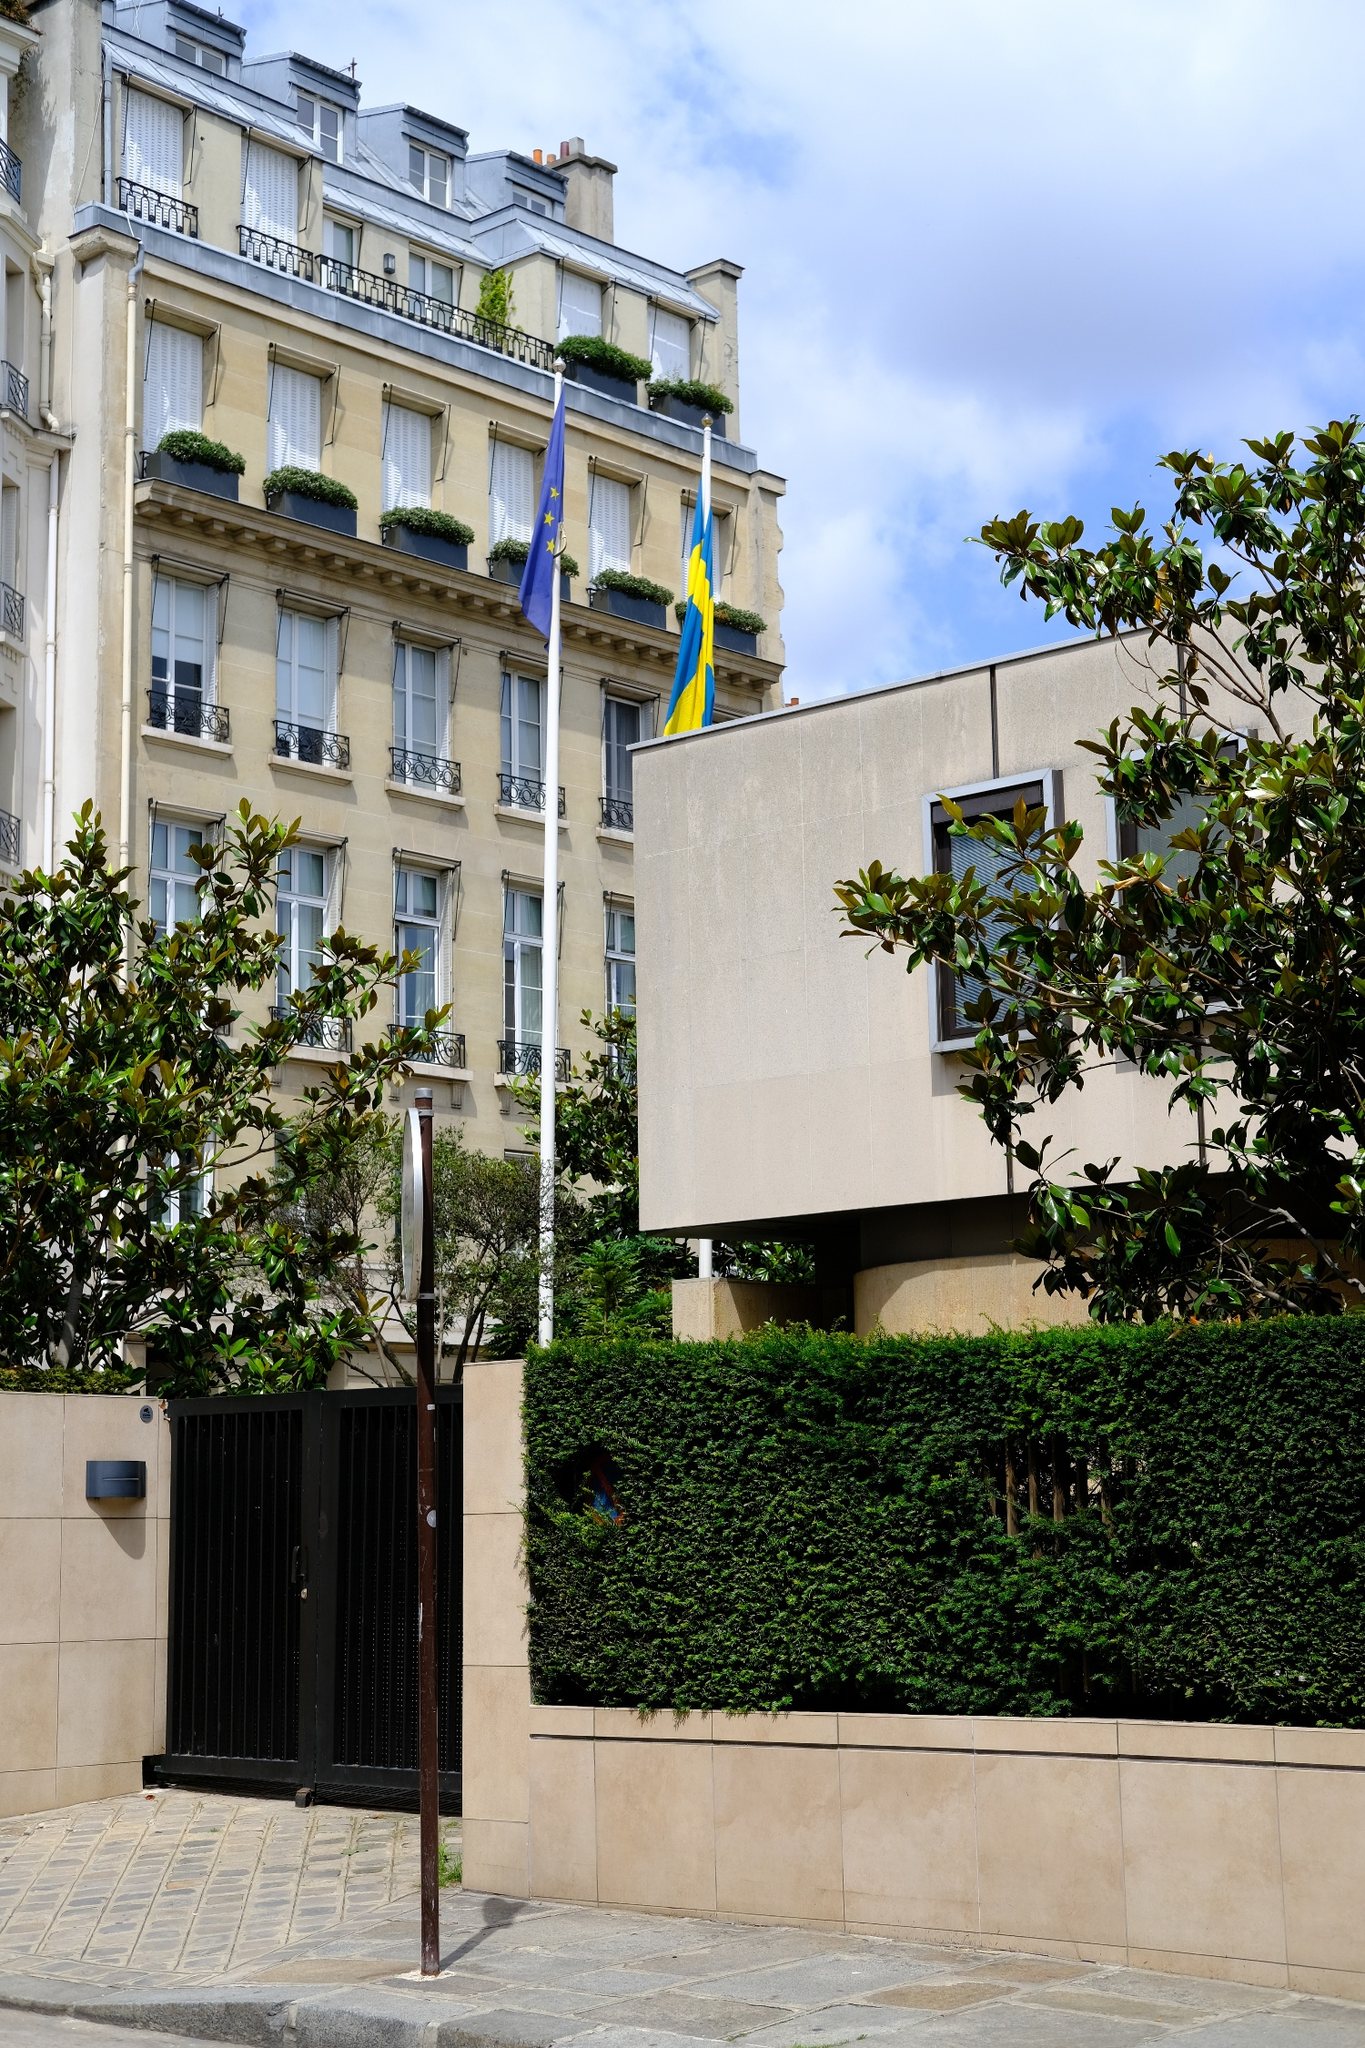Imagine you are a bird flying over this scene. Describe what you see from above. As a bird soaring overhead, the cityscape unfolds beneath in a breathtaking panorama. Below, the stately beige building stands proudly amidst a tapestry of similarly elegant structures. The rooftop gardens, decorated with pots of verdant plants, add vibrant splashes of green that contrast beautifully against the muted roofing tiles. The flags of the European Union and Sweden flutter in the gentle breeze, visible from my lofty perch. The cobblestone streets wind like ribbons through the scene, lined with lush trees that punctuate the urban landscape with nature’s touch. From above, the hustle and bustle of the city become a soft hum, and the overall view is one of harmony and poetic beauty. 